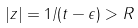<formula> <loc_0><loc_0><loc_500><loc_500>| z | = 1 / ( t - \epsilon ) > R</formula> 